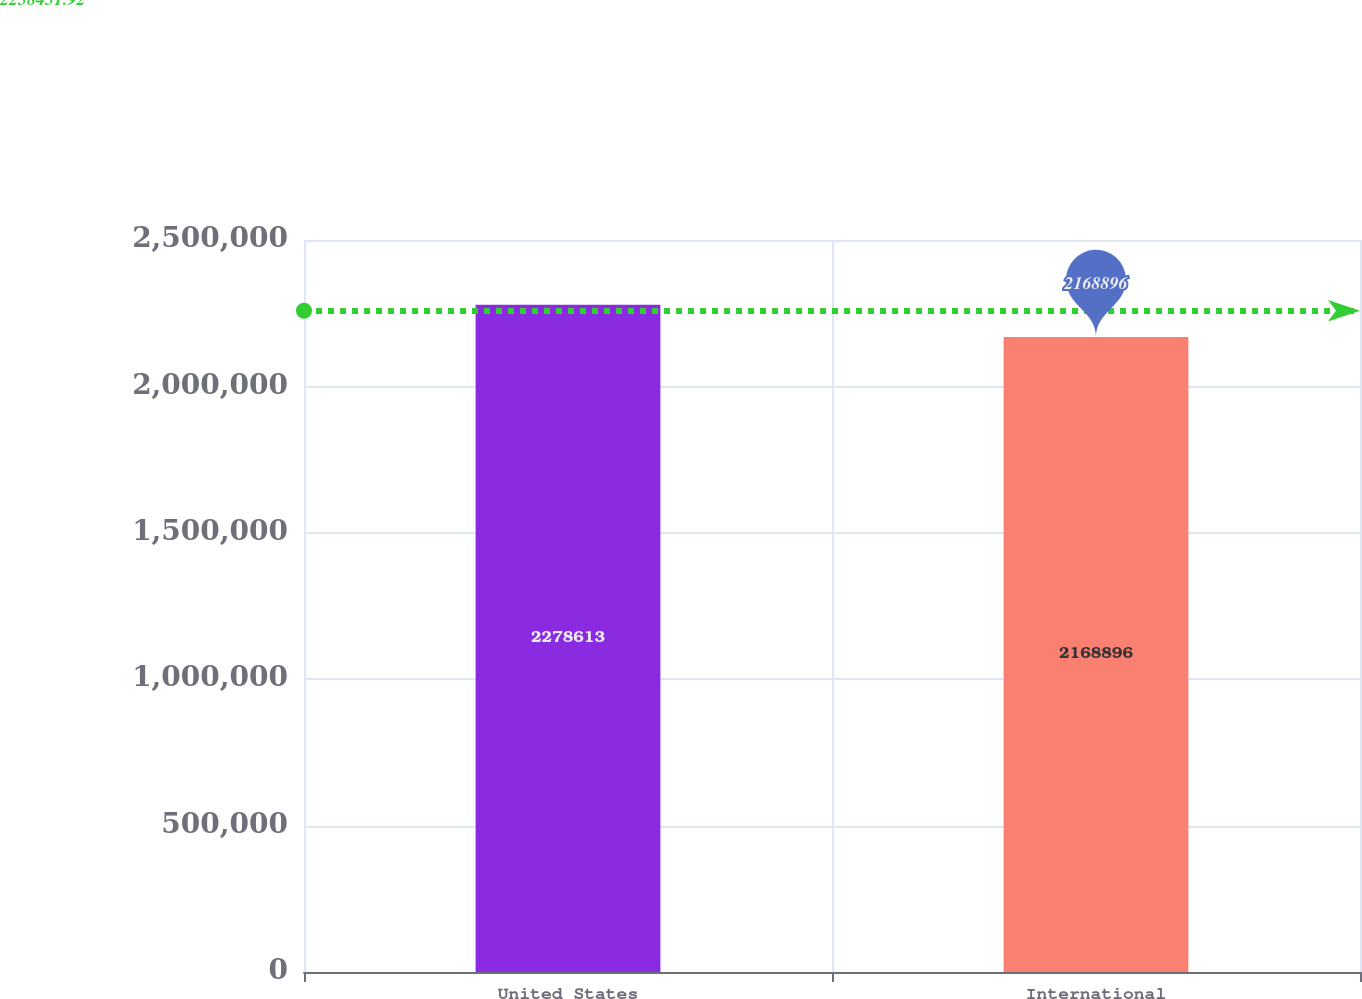Convert chart to OTSL. <chart><loc_0><loc_0><loc_500><loc_500><bar_chart><fcel>United States<fcel>International<nl><fcel>2.27861e+06<fcel>2.1689e+06<nl></chart> 